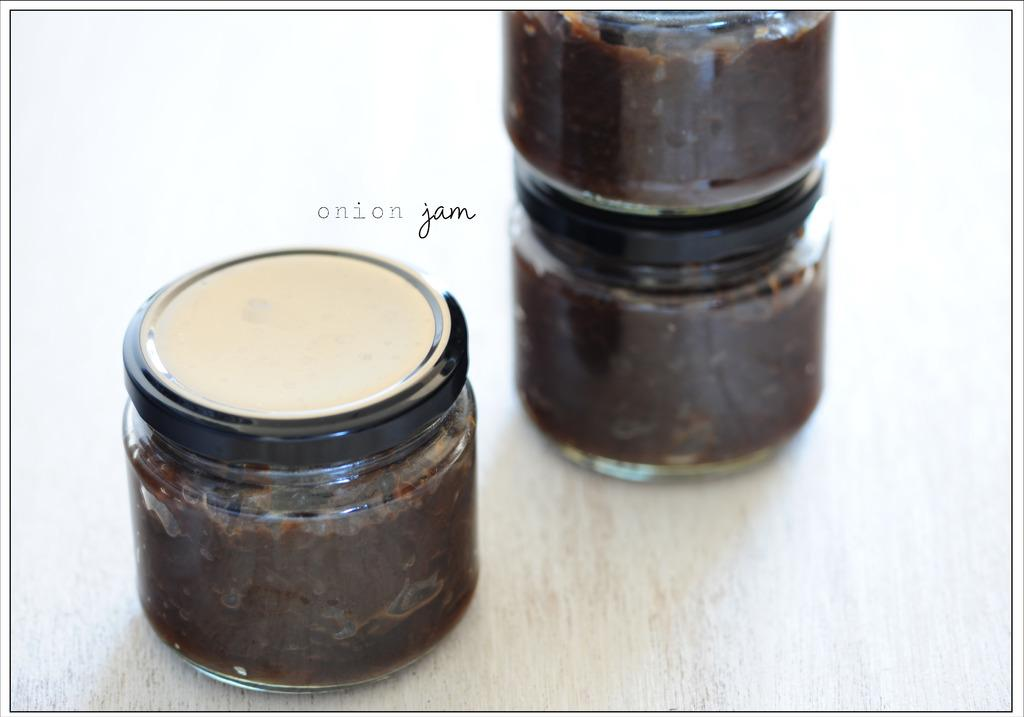<image>
Offer a succinct explanation of the picture presented. Three small jars of Onion Jam set on a table. 